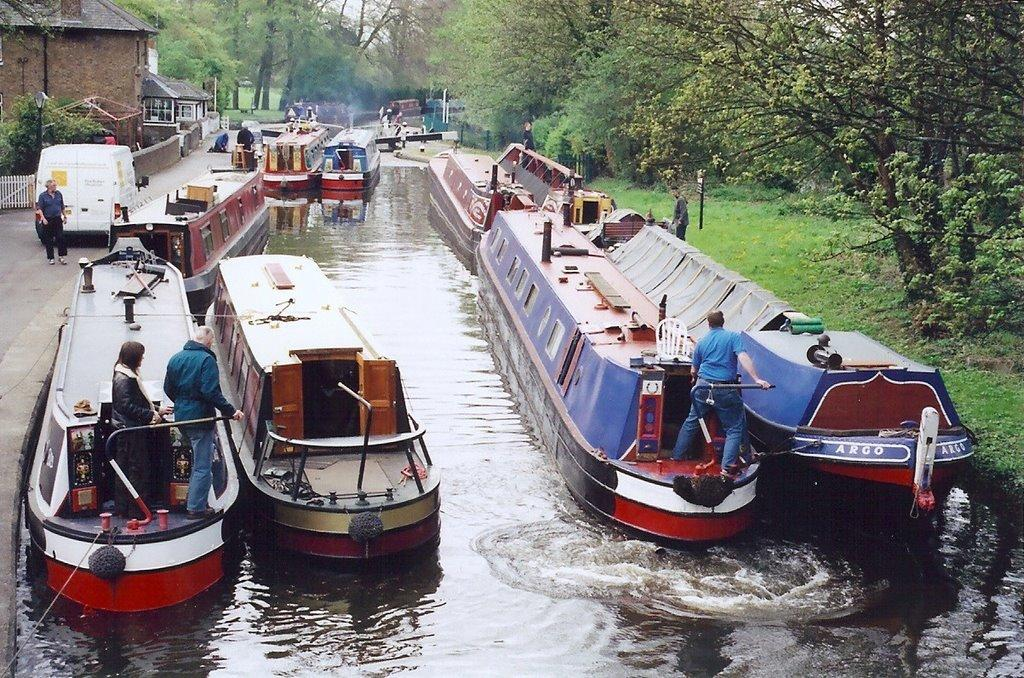<image>
Relay a brief, clear account of the picture shown. A man is standing on a boat that has the word Argo on the front. 